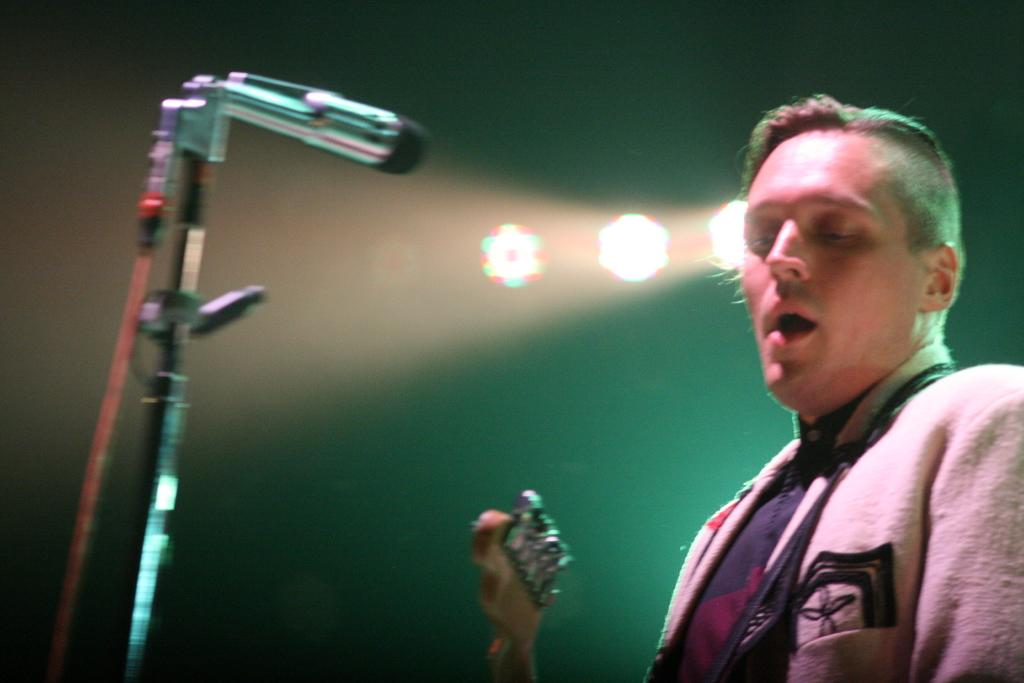Who is present on the right side of the image? There is a person on the right side of the image. What is the person holding in the image? The person is holding a guitar. What object is in front of the person? There is a microphone in front of the person. What can be seen behind the person in the image? There are lights visible behind the person. What type of stone is the person standing on in the image? There is no stone visible in the image; the person is standing on a floor or stage. 